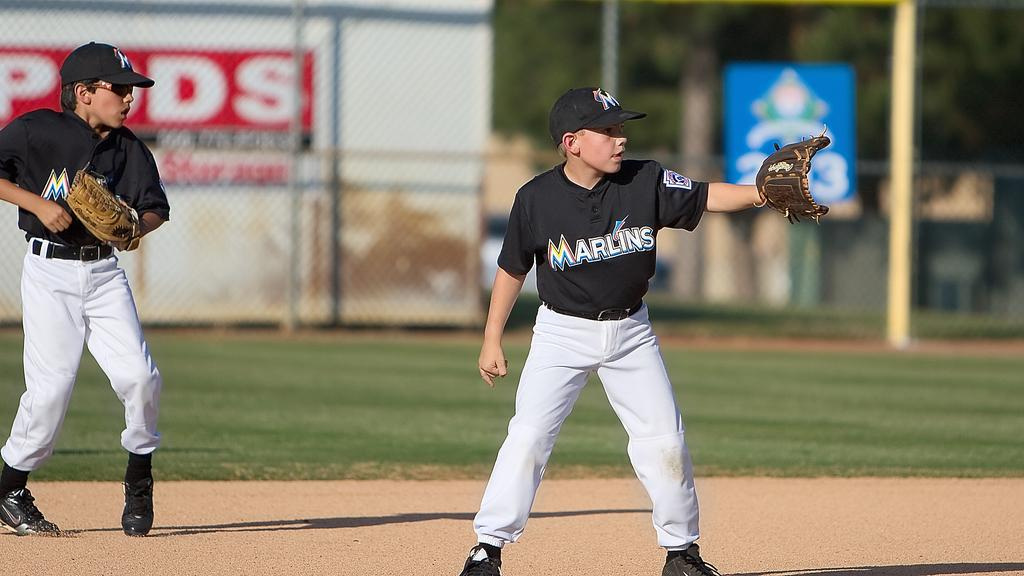Provide a one-sentence caption for the provided image. 2 men playing basball with marlins written across. 